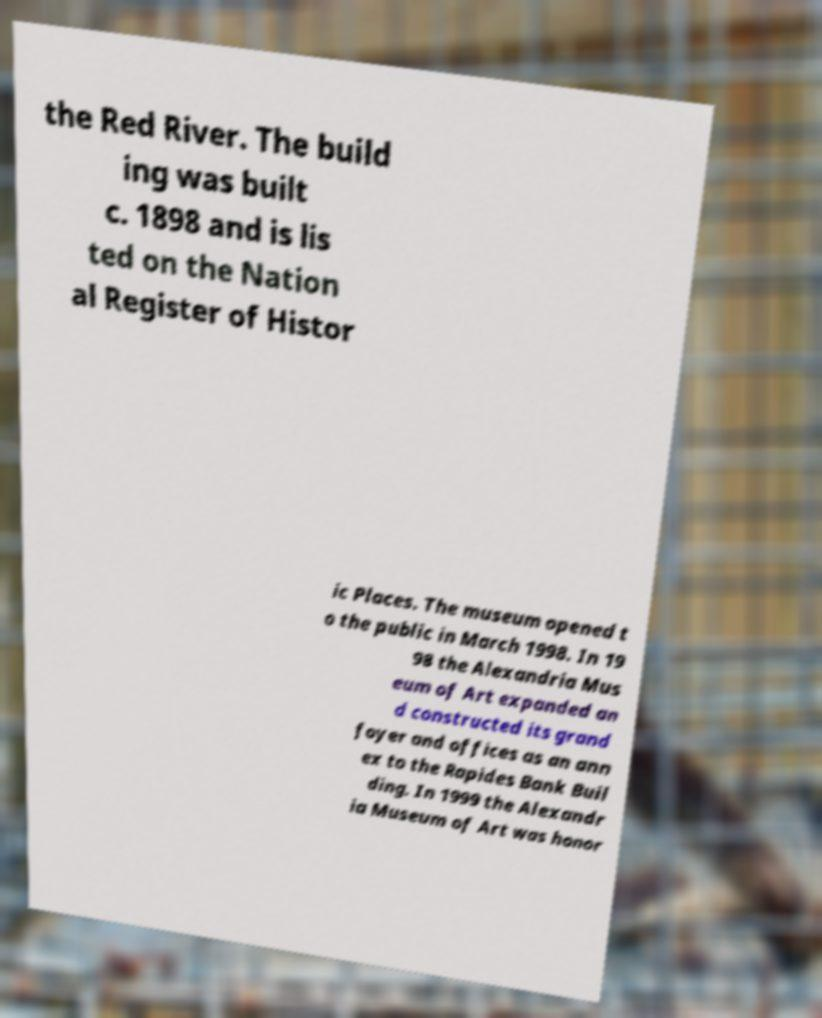Could you extract and type out the text from this image? the Red River. The build ing was built c. 1898 and is lis ted on the Nation al Register of Histor ic Places. The museum opened t o the public in March 1998. In 19 98 the Alexandria Mus eum of Art expanded an d constructed its grand foyer and offices as an ann ex to the Rapides Bank Buil ding. In 1999 the Alexandr ia Museum of Art was honor 